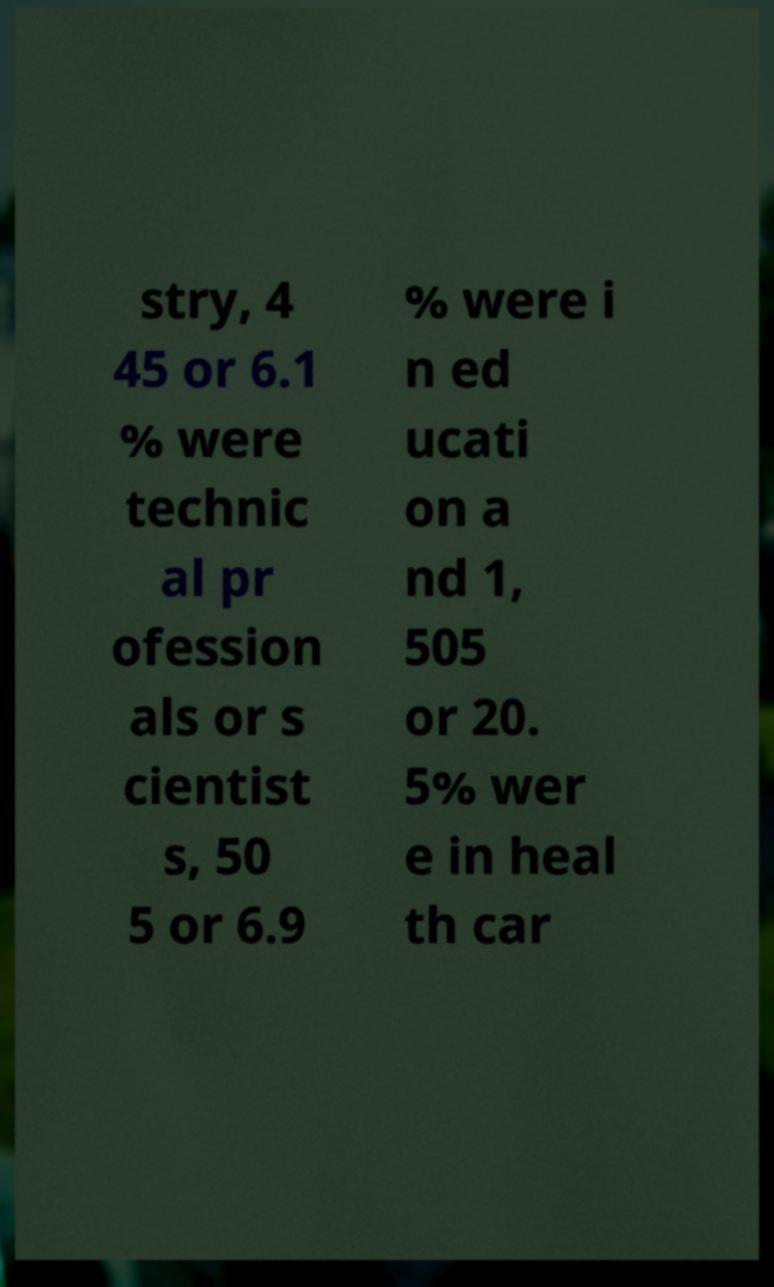Can you read and provide the text displayed in the image?This photo seems to have some interesting text. Can you extract and type it out for me? stry, 4 45 or 6.1 % were technic al pr ofession als or s cientist s, 50 5 or 6.9 % were i n ed ucati on a nd 1, 505 or 20. 5% wer e in heal th car 